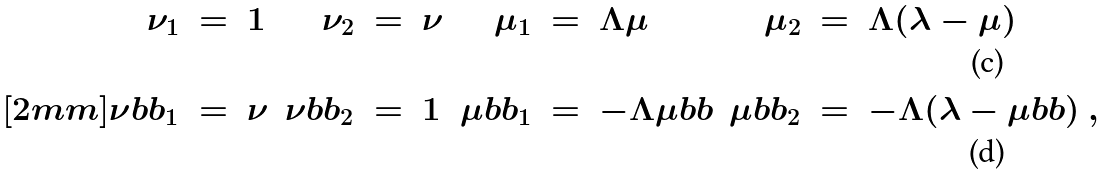<formula> <loc_0><loc_0><loc_500><loc_500>\nu _ { 1 } & \ = \ 1 & \nu _ { 2 } & \ = \ \nu & \mu _ { 1 } & \ = \ \Lambda \mu & \mu _ { 2 } & \ = \ \Lambda ( \lambda - \mu ) \\ [ 2 m m ] \nu b b _ { 1 } & \ = \ \nu & \nu b b _ { 2 } & \ = \ 1 & \mu b b _ { 1 } & \ = \ - \Lambda \mu b b & \mu b b _ { 2 } & \ = \ - \Lambda ( \lambda - \mu b b ) \ ,</formula> 